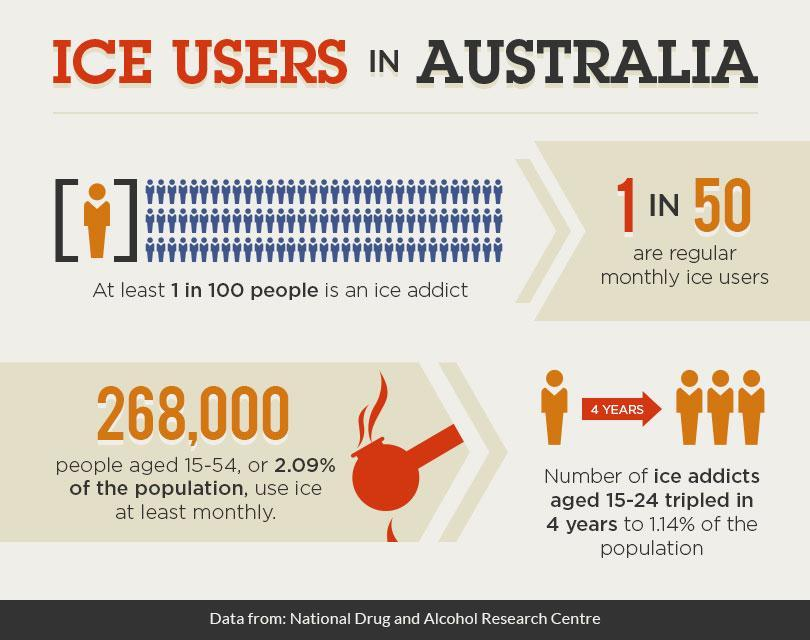what is written in the arrow
Answer the question with a short phrase. 4 years what percentage of population use ice monthly 2.09% how many are monthly ice users 1 in 50 